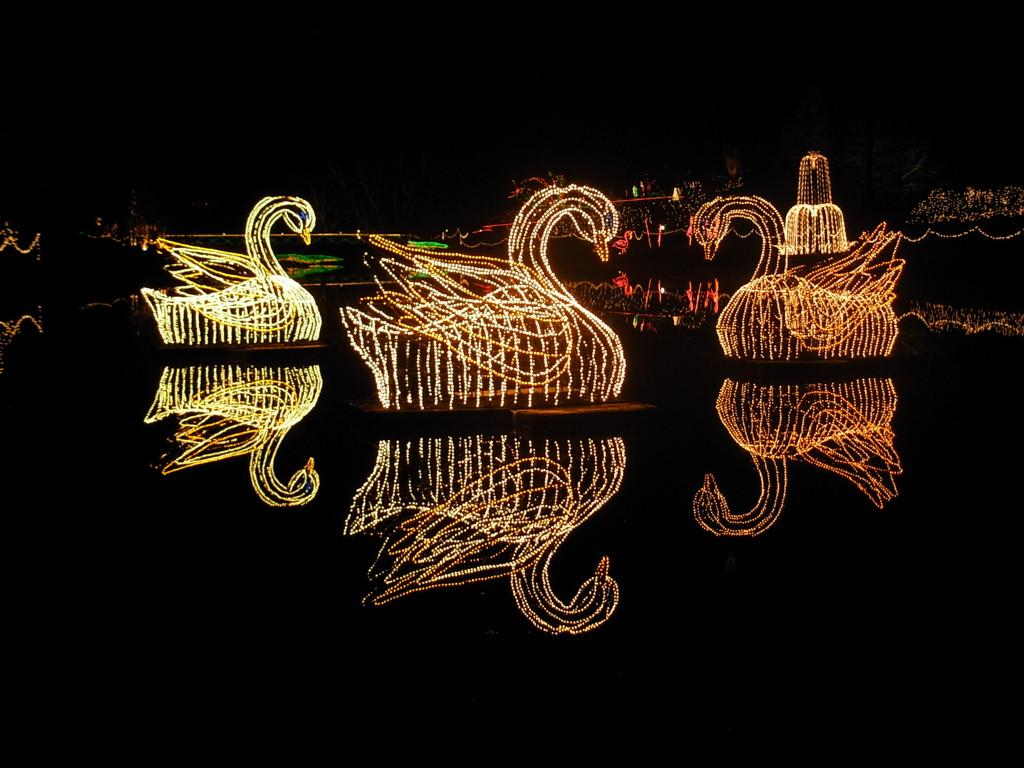What type of objects have decorative lights in the image? The image shows objects with decorative lights, but it does not specify the exact type of objects. Can you describe the appearance of the decorative lights? Unfortunately, the facts provided do not give any information about the appearance of the decorative lights. Are there any other elements in the image besides the objects with decorative lights? The facts only mention the presence of objects with decorative lights, so there is no information about other elements in the image. Where is the man standing in the image? There is no mention of a man in the image, so we cannot answer this question. What type of bucket is being used to hold the decorative lights? There is no mention of a bucket in the image, so we cannot answer this question. 